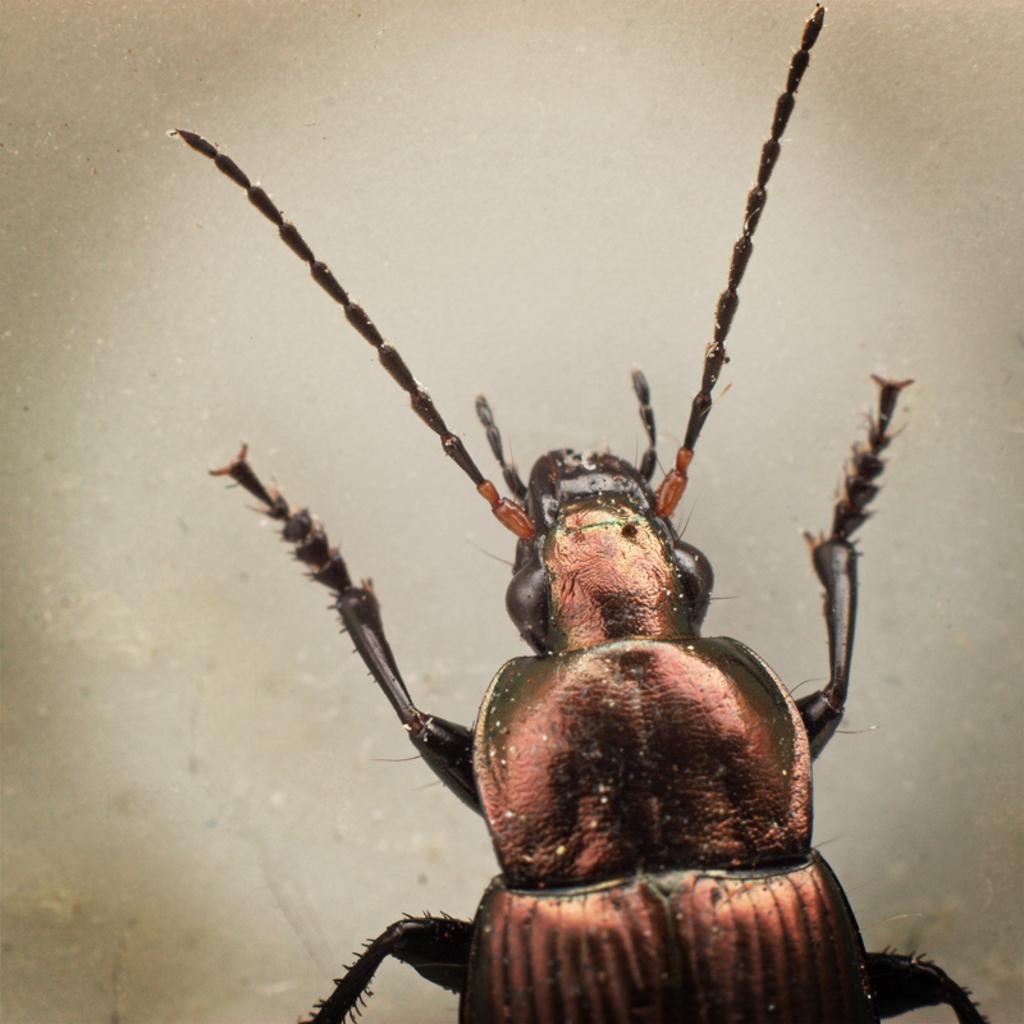In one or two sentences, can you explain what this image depicts? In the image there is a bug standing on the floor. 